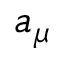Convert formula to latex. <formula><loc_0><loc_0><loc_500><loc_500>a _ { \mu }</formula> 